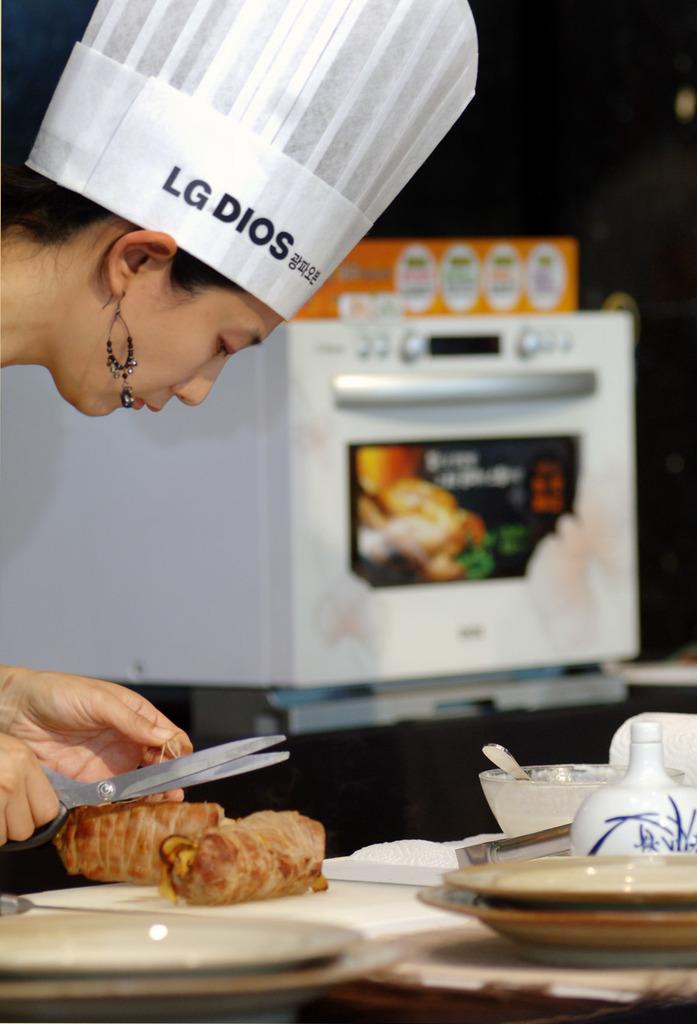What does her hat say in english?
Your answer should be compact. Unanswerable. Are the letters on the chef hat black?
Your answer should be very brief. Lg dios. 